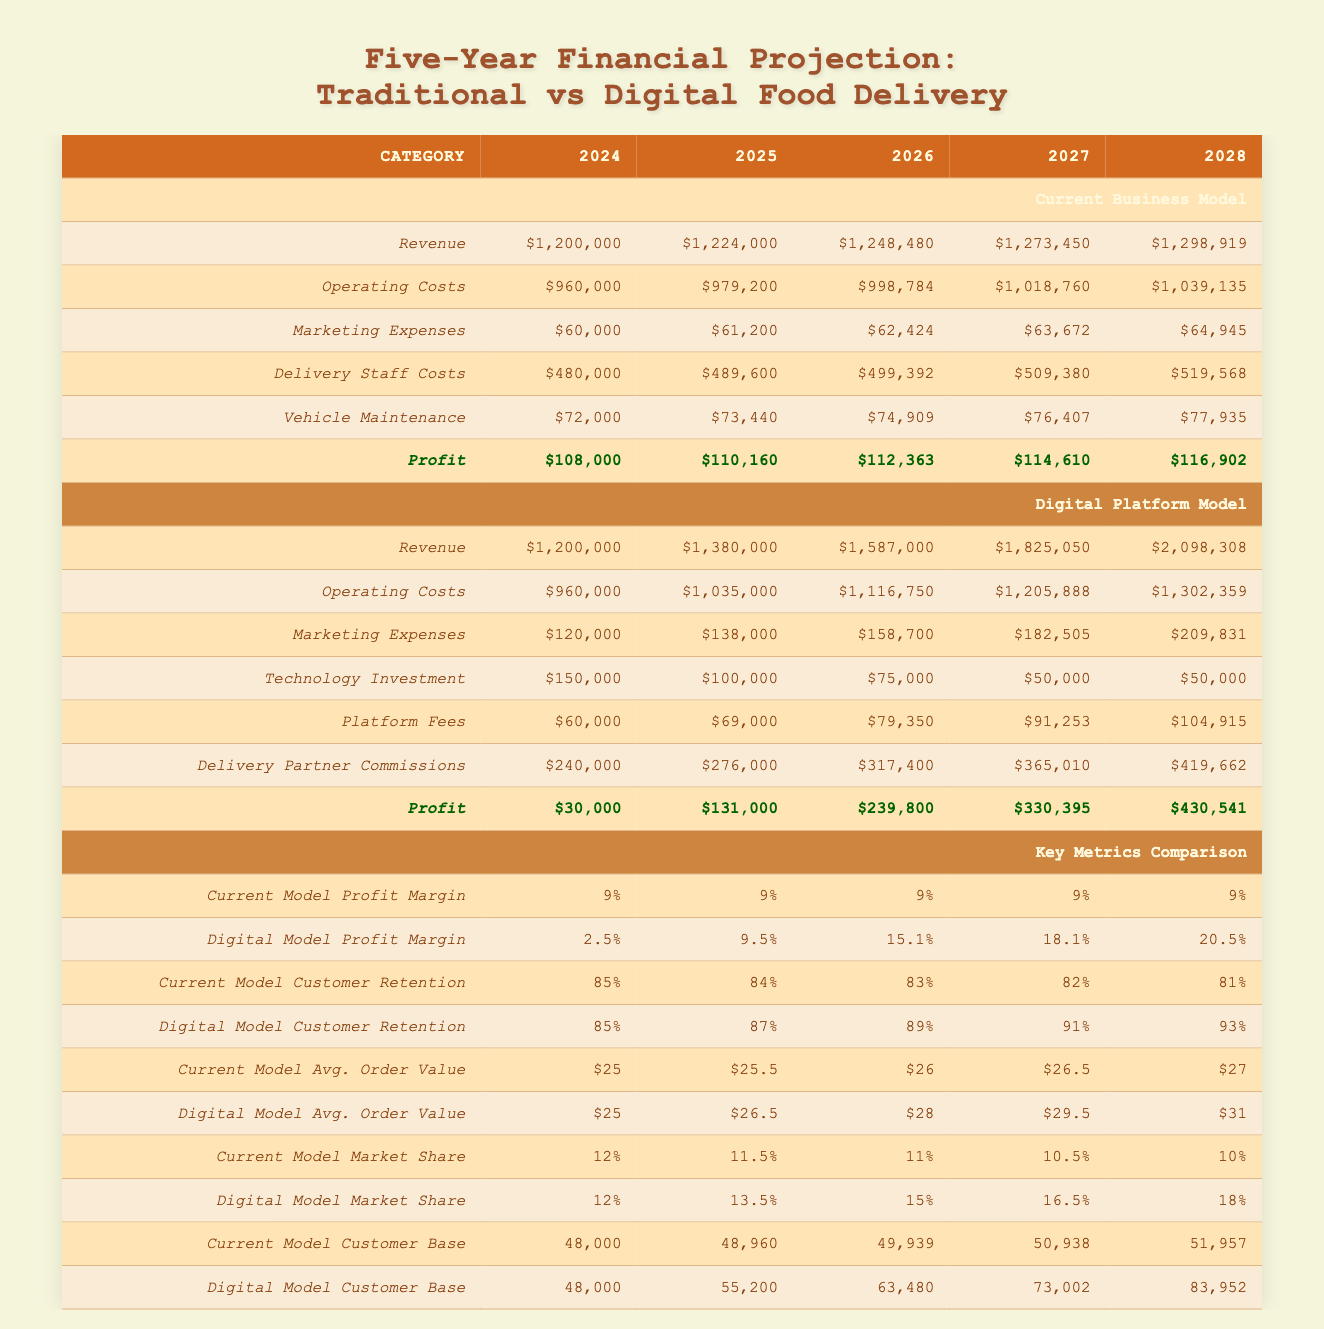What was the profit of the current model in 2026? The profit of the current model in 2026 can be found in the appropriate row and column in the table. Referring to the profit row under the current business model for 2026, the value is $112,363.
Answer: $112,363 In which year does the digital model achieve the highest profit? To find the year with the highest profit for the digital model, we need to look at the profit row under the digital model for each year and identify the maximum value. In 2028, the digital model has the highest profit of $430,541.
Answer: 2028 What is the average growth rate of revenue in the digital model from 2024 to 2028? The revenue for the digital model in 2024 is $1,200,000 and in 2028 is $2,098,308. The growth in revenue is calculated by subtracting the 2024 revenue from the 2028 revenue and dividing by the initial value: (2,098,308 - 1,200,000) / 1,200,000 = 0.749; so, the average growth rate is 74.9%.
Answer: 74.9% Is the current model's customer retention rate decreasing over the years? To determine if the current model's customer retention rate is decreasing, we look at the customer retention rates for each year from 2024 to 2028. The values are 85%, 84%, 83%, 82%, and 81%. Since these values consistently decline, the statement is true.
Answer: Yes What is the total operating costs for the digital model over five years? The total operating costs for the digital model can be found by summing the specific operating costs listed for each year: 960,000 + 1,035,000 + 1,116,750 + 1,205,888 + 1,302,359 = 5,620,997.
Answer: $5,620,997 